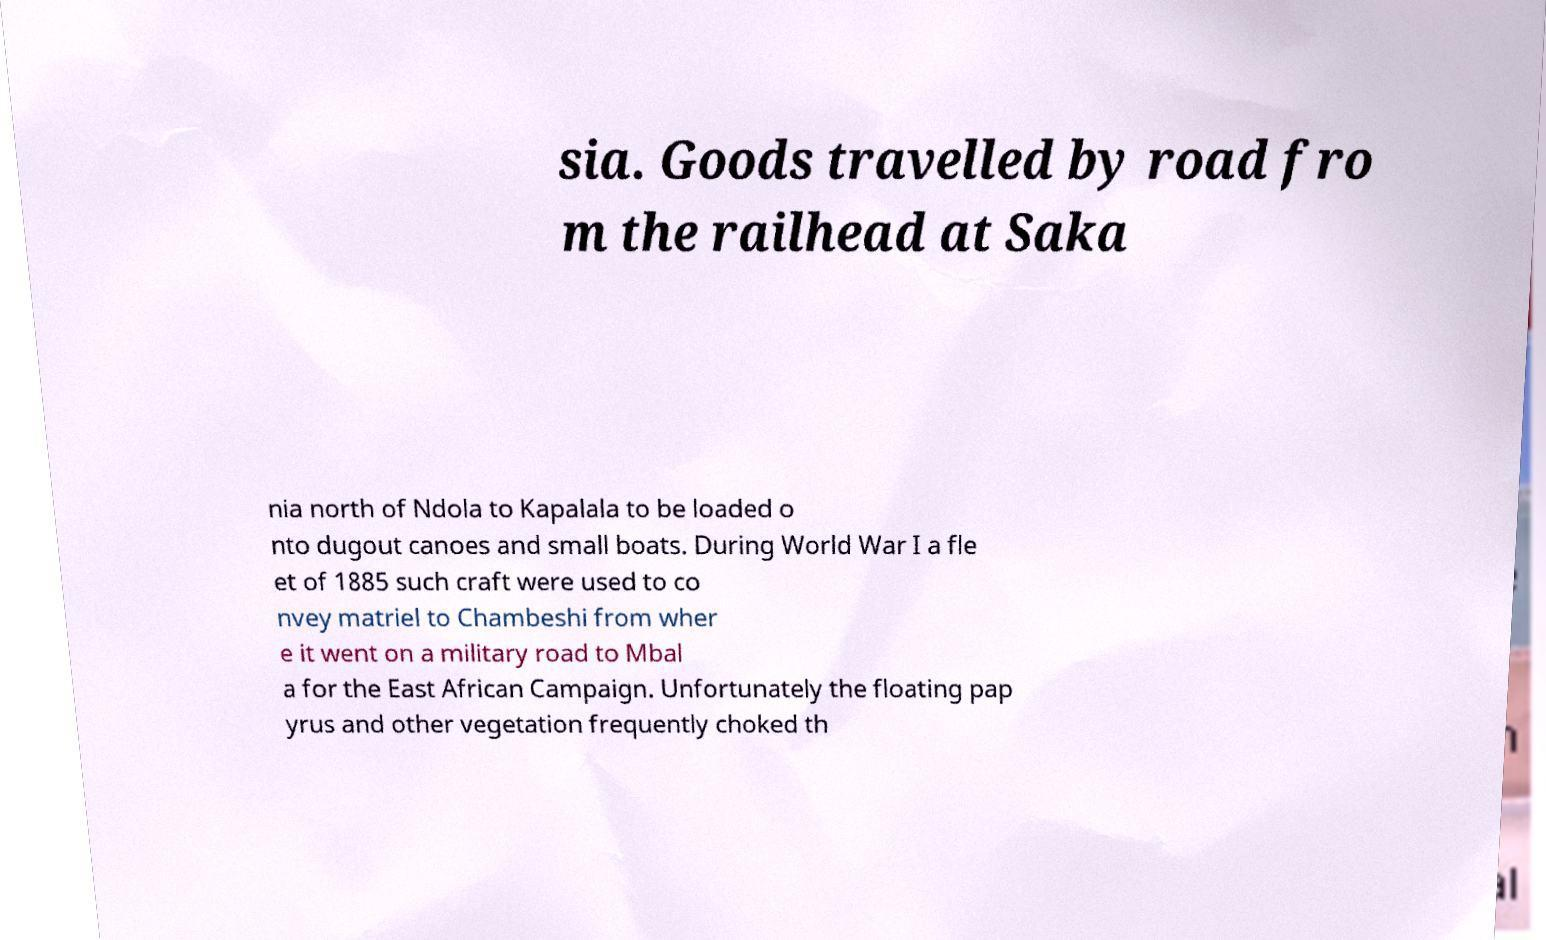For documentation purposes, I need the text within this image transcribed. Could you provide that? sia. Goods travelled by road fro m the railhead at Saka nia north of Ndola to Kapalala to be loaded o nto dugout canoes and small boats. During World War I a fle et of 1885 such craft were used to co nvey matriel to Chambeshi from wher e it went on a military road to Mbal a for the East African Campaign. Unfortunately the floating pap yrus and other vegetation frequently choked th 